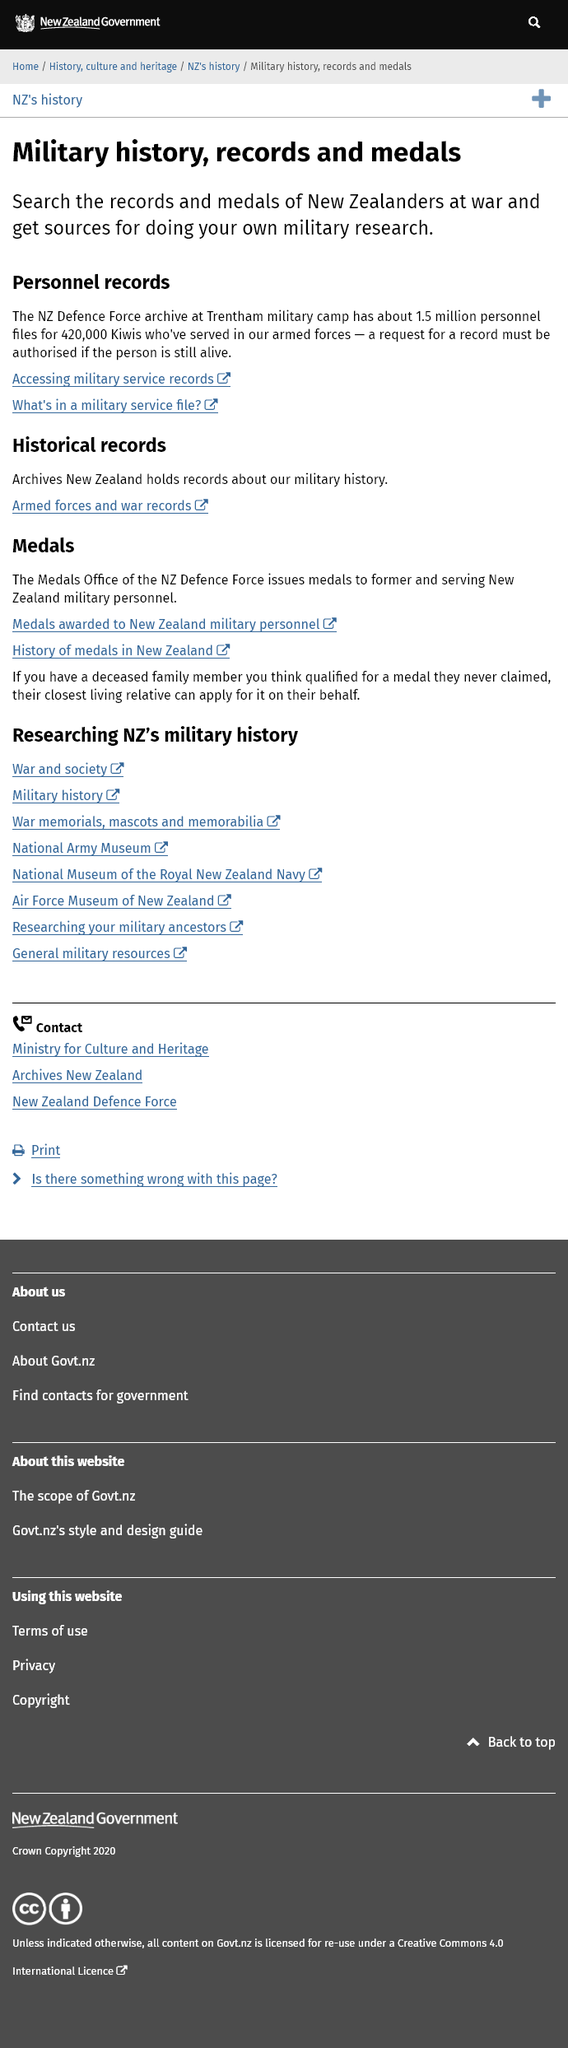Draw attention to some important aspects in this diagram. The person is seeking information on personnel files and believes they can be found at the New Zealand Defence Force archive. The New Zealand Defence Force is located at Trentham Military Camp. The location where access to military service records can be obtained is the NZ Defence Force Archive at Trentham Military Camp. 